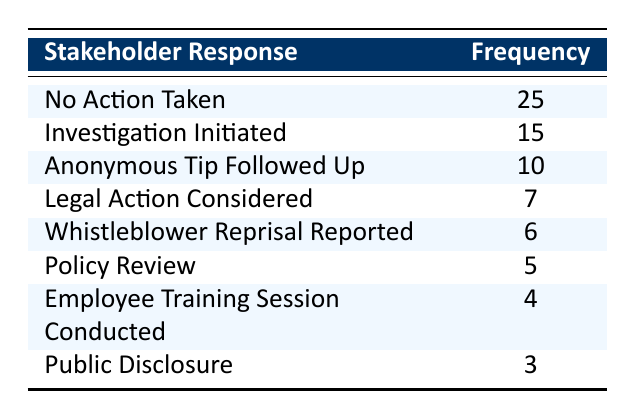What is the frequency of "Investigation Initiated"? The table lists "Investigation Initiated" with a frequency of 15.
Answer: 15 Which response had the highest frequency? Looking at the frequencies in the table, "No Action Taken" has the highest frequency of 25.
Answer: No Action Taken How many responses were related to "Legal Action"? There is one instance of "Legal Action Considered" with a count of 7. Since there are no other instances related to legal action, the total is 7.
Answer: 7 What is the sum of "Anonymous Tip Followed Up" and "Whistleblower Reprisal Reported"? The frequency for "Anonymous Tip Followed Up" is 10 and for "Whistleblower Reprisal Reported" is 6. Adding these together gives 10 + 6 = 16.
Answer: 16 Is it true that there are more instances of "Public Disclosure" than "Policy Review"? The frequency for "Public Disclosure" is 3 and for "Policy Review" is 5. Since 3 is less than 5, the statement is false.
Answer: False What is the average frequency of the actions that resulted in no action taken versus actions that resulted in investigation initiation? The frequency for "No Action Taken" is 25 and for "Investigation Initiated" is 15. The average is (25 + 15) / 2 = 20.
Answer: 20 How many total responses were recorded in the table? To find the total responses, we sum all the frequencies listed: 25 + 15 + 10 + 7 + 6 + 5 + 4 + 3 = 75.
Answer: 75 Which response had the least frequency, and what was that frequency? The lowest frequency in the table is "Public Disclosure" with a frequency of 3.
Answer: Public Disclosure, 3 What is the difference between the counts of "No Action Taken" and "Investigation Initiated"? The count for "No Action Taken" is 25 and for "Investigation Initiated" is 15. The difference is 25 - 15 = 10.
Answer: 10 